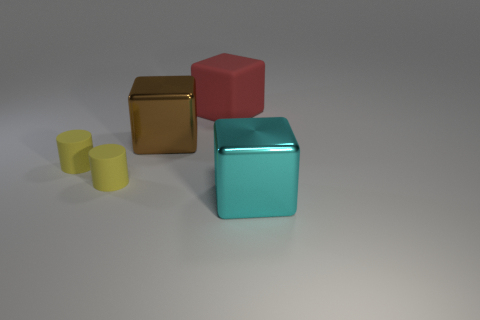The big rubber object has what color?
Make the answer very short. Red. What number of large brown objects are the same shape as the cyan thing?
Keep it short and to the point. 1. Do the big thing that is in front of the big brown thing and the big thing that is left of the big red thing have the same material?
Make the answer very short. Yes. There is a metal object that is on the left side of the object to the right of the large rubber object; how big is it?
Make the answer very short. Large. Is there any other thing that has the same size as the cyan metal object?
Ensure brevity in your answer.  Yes. What material is the other brown thing that is the same shape as the big rubber thing?
Provide a short and direct response. Metal. There is a large brown metallic object behind the large cyan metal thing; is its shape the same as the shiny thing that is to the right of the big rubber thing?
Offer a terse response. Yes. Is the number of tiny cyan spheres greater than the number of brown shiny cubes?
Offer a terse response. No. What size is the rubber block?
Provide a succinct answer. Large. What number of other things are the same color as the matte cube?
Your answer should be very brief. 0. 